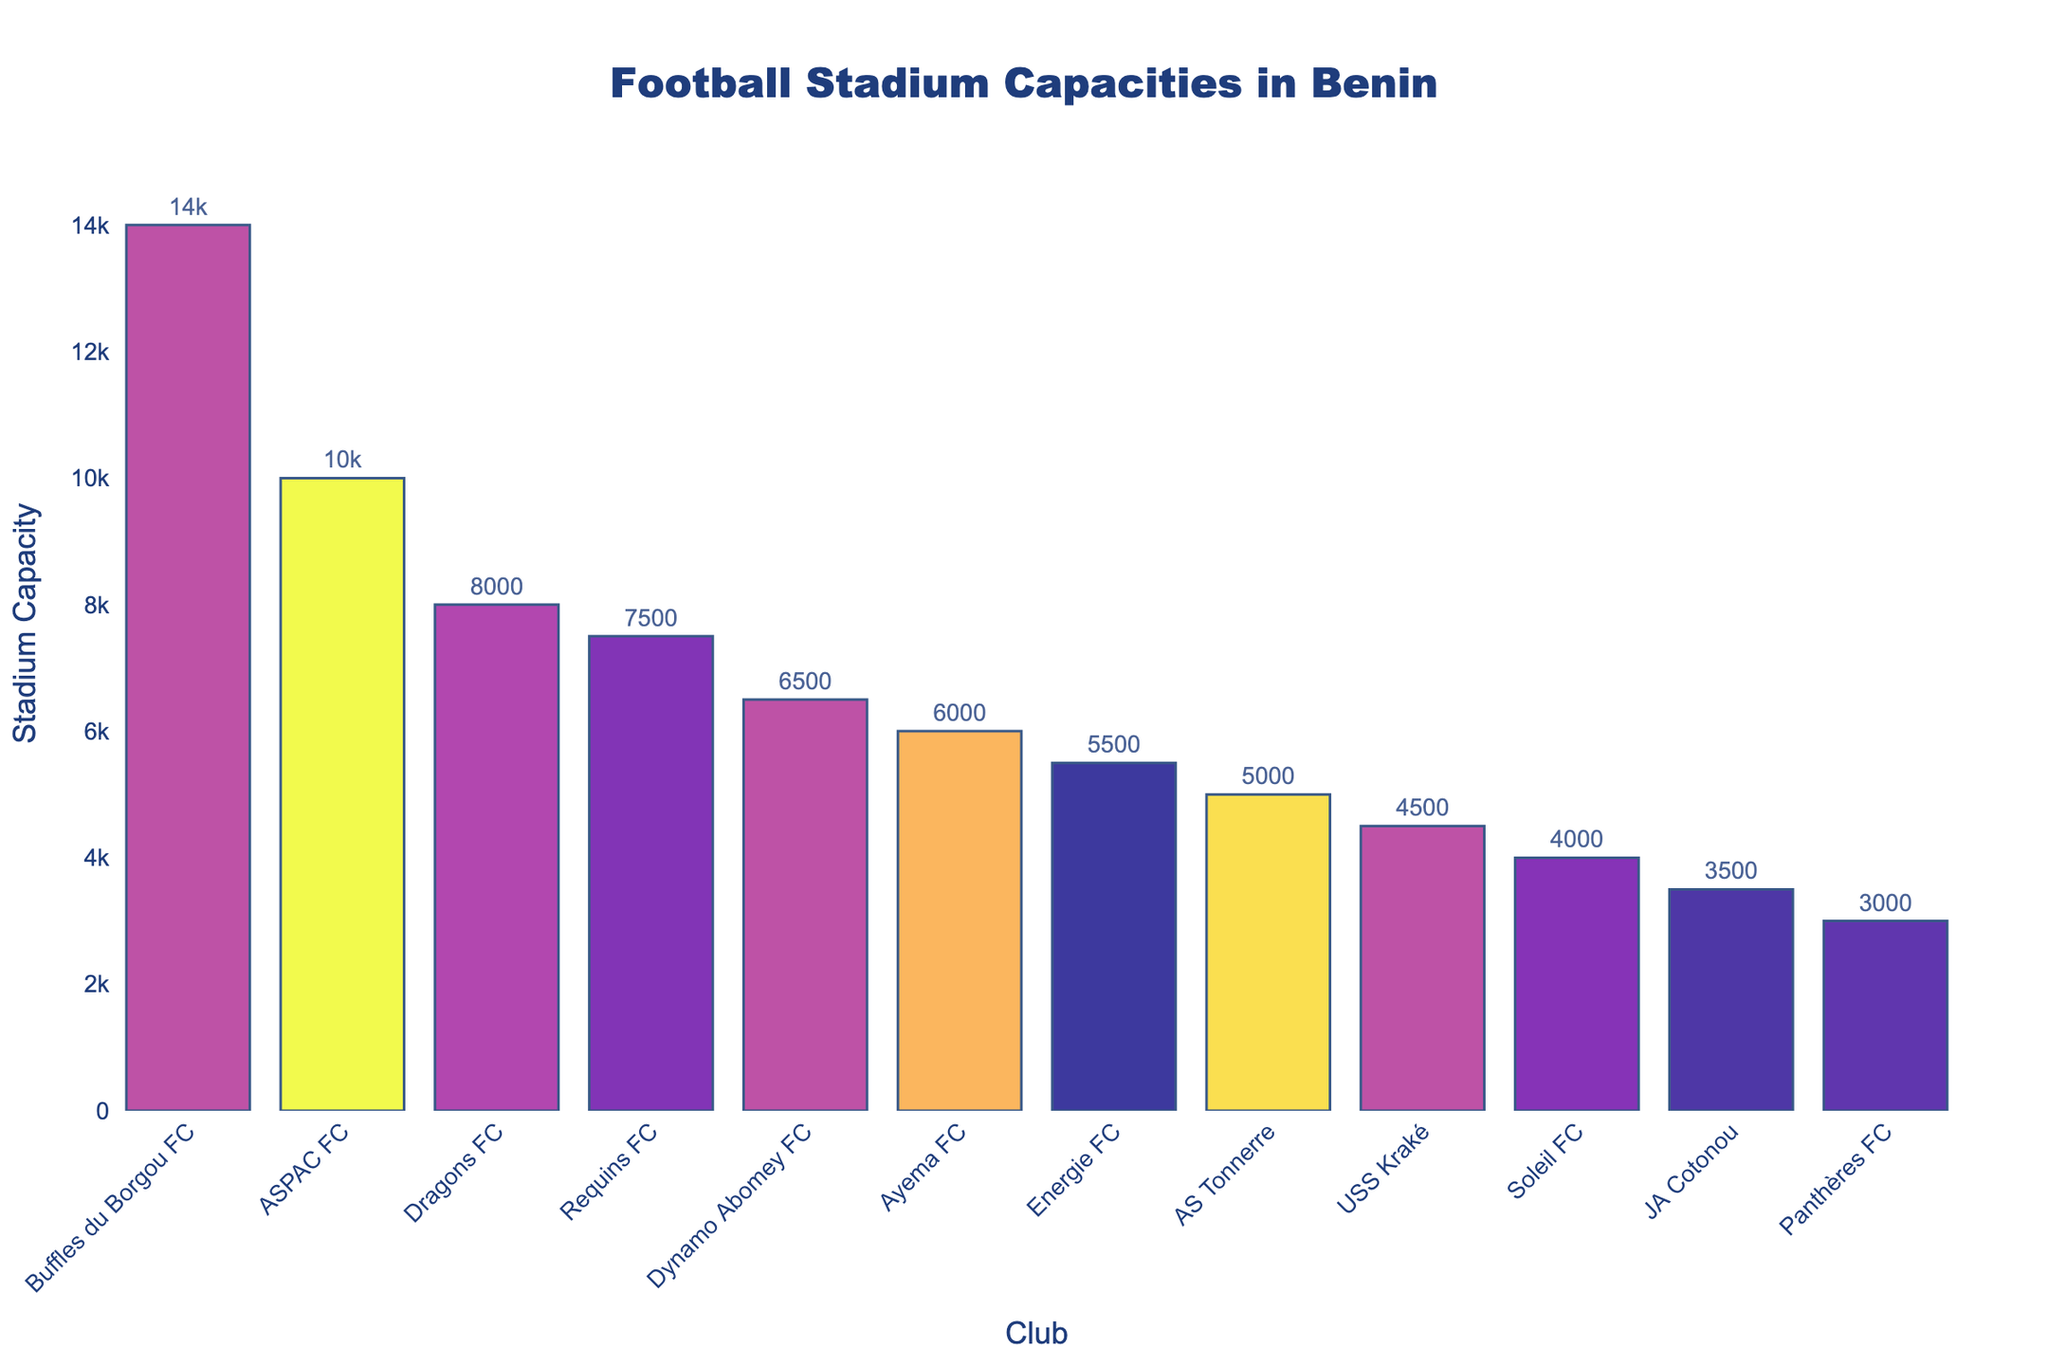Which club has the largest stadium capacity? By examining the tallest bar in the bar chart and referring to the x-axis labels, we identify the club with the highest value on the y-axis.
Answer: Buffles du Borgou FC How much larger is the stadium capacity of Buffles du Borgou FC compared to USS Kraké? First, find the capacities of both clubs: Buffles du Borgou FC has 14,000, and USS Kraké has 4,500. Subtract the smaller capacity from the larger capacity: 14,000 - 4,500 = 9,500.
Answer: 9,500 Which two clubs have the closest stadium capacities? Scan the bars for pairs that have similar heights and then check their y-axis values. Dynamo Abomey FC (6,500) and Ayema FC (6,000) are closest with a difference of 500.
Answer: Dynamo Abomey FC and Ayema FC What is the sum of the stadium capacities for Energie FC and AS Tonnerre? Find the capacities of both clubs: Energie FC has 5,500 and AS Tonnerre has 5,000. Sum these values: 5,500 + 5,000 = 10,500.
Answer: 10,500 Which club has the smallest stadium capacity and what is it? Identify the shortest bar on the bar chart and refer to the corresponding x-axis label and y-axis value.
Answer: Panthères FC, 3,000 Which clubs have stadium capacities greater than 7,000? Identify bars with y-axis values above 7,000 and check their corresponding x-axis labels: Buffles du Borgou FC, ASPAC FC, Dragons FC, and Requins FC.
Answer: Buffles du Borgou FC, ASPAC FC, Dragons FC, Requins FC What is the average stadium capacity of the clubs shown? Sum the capacities of all clubs and divide by the number of clubs. Sum: 14,000 + 10,000 + 8,000 + 7,500 + 6,500 + 6,000 + 5,500 + 5,000 + 4,500 + 4,000 + 3,500 + 3,000 = 77,500. Divide by 12: 77,500 / 12 ≈ 6,458.33.
Answer: 6,458.33 Which club has the third largest stadium capacity? Rank the bars by height and identify the third highest, which corresponds to Dragons FC with a capacity of 8,000.
Answer: Dragons FC By how much does the capacity of ASPAC FC's stadium exceed that of JA Cotonou's? Subtract the smaller capacity from the larger capacity: ASPAC FC (10,000) - JA Cotonou (3,500) = 6,500.
Answer: 6,500 What is the difference in capacity between the largest and smallest stadiums? Find the largest capacity (14,000) and smallest capacity (3,000), then subtract: 14,000 - 3,000 = 11,000.
Answer: 11,000 